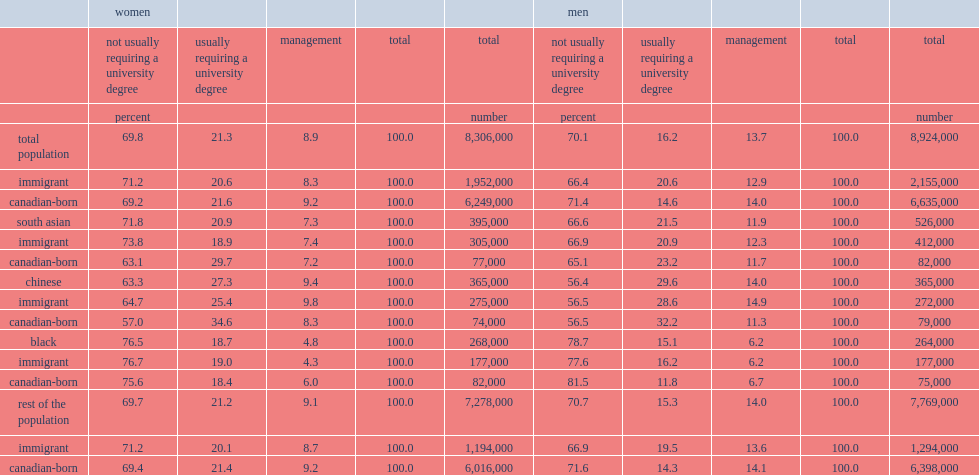What was the proportion of female workers that were in occupations that did not usually require a university degree? 69.8. What was the proportion of male workers that were in occupations that did not usually require a university degree? 70.1. 